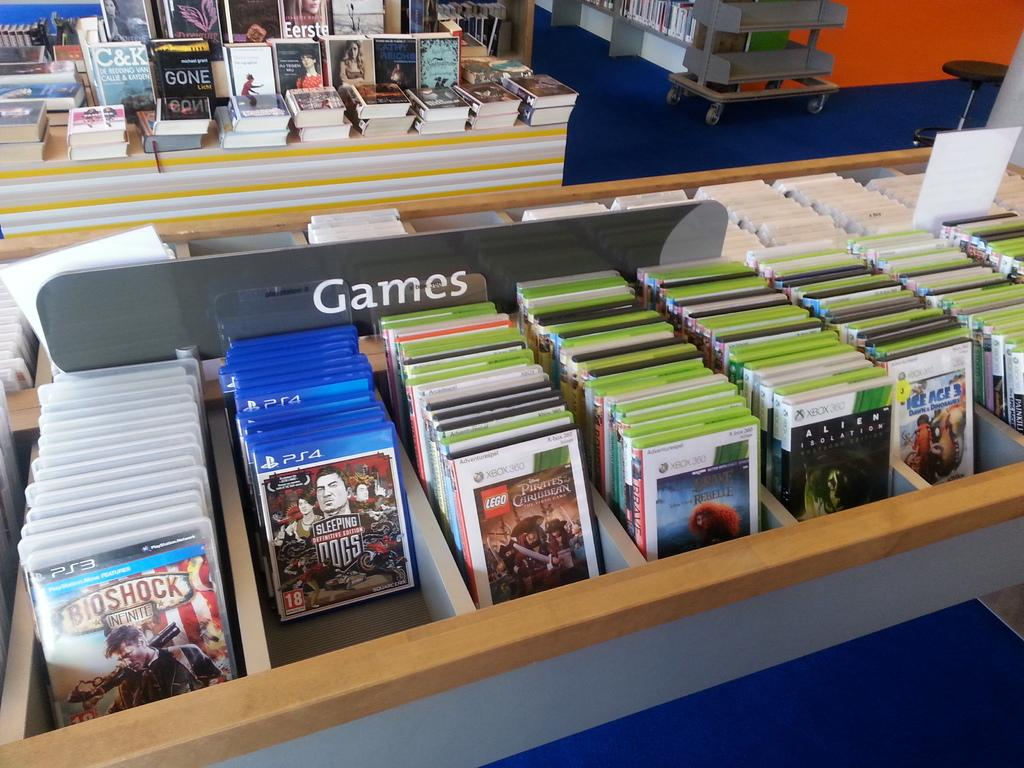<image>
Summarize the visual content of the image. A store rack full of video games has a label sign that reads "Games". 